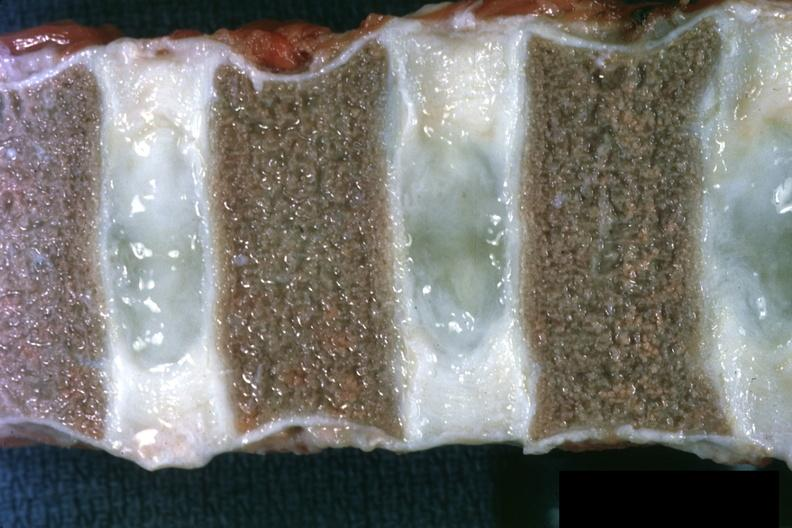s stomach present?
Answer the question using a single word or phrase. No 